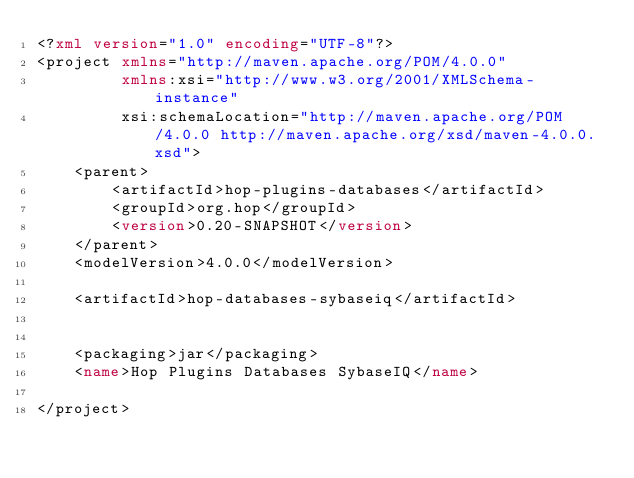<code> <loc_0><loc_0><loc_500><loc_500><_XML_><?xml version="1.0" encoding="UTF-8"?>
<project xmlns="http://maven.apache.org/POM/4.0.0"
         xmlns:xsi="http://www.w3.org/2001/XMLSchema-instance"
         xsi:schemaLocation="http://maven.apache.org/POM/4.0.0 http://maven.apache.org/xsd/maven-4.0.0.xsd">
    <parent>
        <artifactId>hop-plugins-databases</artifactId>
        <groupId>org.hop</groupId>
        <version>0.20-SNAPSHOT</version>
    </parent>
    <modelVersion>4.0.0</modelVersion>

    <artifactId>hop-databases-sybaseiq</artifactId>


    <packaging>jar</packaging>
    <name>Hop Plugins Databases SybaseIQ</name>

</project></code> 